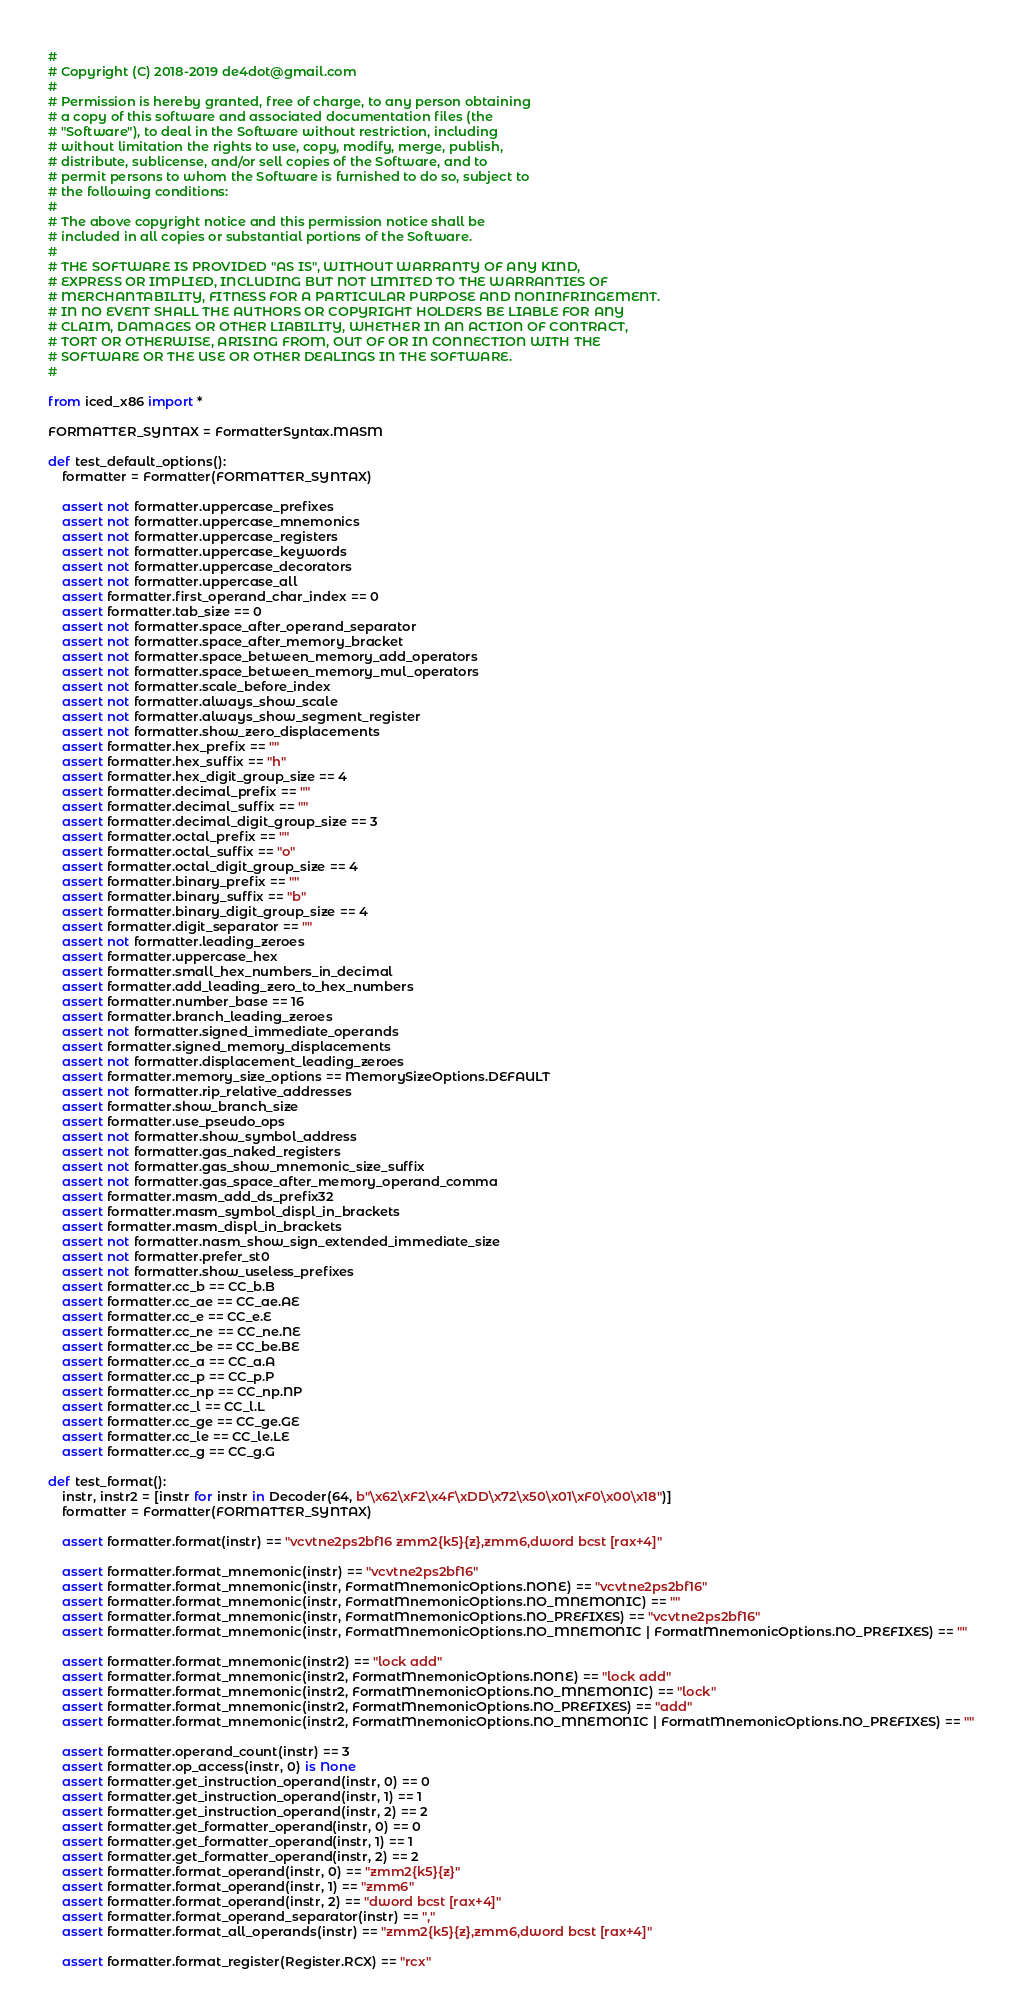<code> <loc_0><loc_0><loc_500><loc_500><_Python_>#
# Copyright (C) 2018-2019 de4dot@gmail.com
#
# Permission is hereby granted, free of charge, to any person obtaining
# a copy of this software and associated documentation files (the
# "Software"), to deal in the Software without restriction, including
# without limitation the rights to use, copy, modify, merge, publish,
# distribute, sublicense, and/or sell copies of the Software, and to
# permit persons to whom the Software is furnished to do so, subject to
# the following conditions:
#
# The above copyright notice and this permission notice shall be
# included in all copies or substantial portions of the Software.
#
# THE SOFTWARE IS PROVIDED "AS IS", WITHOUT WARRANTY OF ANY KIND,
# EXPRESS OR IMPLIED, INCLUDING BUT NOT LIMITED TO THE WARRANTIES OF
# MERCHANTABILITY, FITNESS FOR A PARTICULAR PURPOSE AND NONINFRINGEMENT.
# IN NO EVENT SHALL THE AUTHORS OR COPYRIGHT HOLDERS BE LIABLE FOR ANY
# CLAIM, DAMAGES OR OTHER LIABILITY, WHETHER IN AN ACTION OF CONTRACT,
# TORT OR OTHERWISE, ARISING FROM, OUT OF OR IN CONNECTION WITH THE
# SOFTWARE OR THE USE OR OTHER DEALINGS IN THE SOFTWARE.
#

from iced_x86 import *

FORMATTER_SYNTAX = FormatterSyntax.MASM

def test_default_options():
	formatter = Formatter(FORMATTER_SYNTAX)

	assert not formatter.uppercase_prefixes
	assert not formatter.uppercase_mnemonics
	assert not formatter.uppercase_registers
	assert not formatter.uppercase_keywords
	assert not formatter.uppercase_decorators
	assert not formatter.uppercase_all
	assert formatter.first_operand_char_index == 0
	assert formatter.tab_size == 0
	assert not formatter.space_after_operand_separator
	assert not formatter.space_after_memory_bracket
	assert not formatter.space_between_memory_add_operators
	assert not formatter.space_between_memory_mul_operators
	assert not formatter.scale_before_index
	assert not formatter.always_show_scale
	assert not formatter.always_show_segment_register
	assert not formatter.show_zero_displacements
	assert formatter.hex_prefix == ""
	assert formatter.hex_suffix == "h"
	assert formatter.hex_digit_group_size == 4
	assert formatter.decimal_prefix == ""
	assert formatter.decimal_suffix == ""
	assert formatter.decimal_digit_group_size == 3
	assert formatter.octal_prefix == ""
	assert formatter.octal_suffix == "o"
	assert formatter.octal_digit_group_size == 4
	assert formatter.binary_prefix == ""
	assert formatter.binary_suffix == "b"
	assert formatter.binary_digit_group_size == 4
	assert formatter.digit_separator == ""
	assert not formatter.leading_zeroes
	assert formatter.uppercase_hex
	assert formatter.small_hex_numbers_in_decimal
	assert formatter.add_leading_zero_to_hex_numbers
	assert formatter.number_base == 16
	assert formatter.branch_leading_zeroes
	assert not formatter.signed_immediate_operands
	assert formatter.signed_memory_displacements
	assert not formatter.displacement_leading_zeroes
	assert formatter.memory_size_options == MemorySizeOptions.DEFAULT
	assert not formatter.rip_relative_addresses
	assert formatter.show_branch_size
	assert formatter.use_pseudo_ops
	assert not formatter.show_symbol_address
	assert not formatter.gas_naked_registers
	assert not formatter.gas_show_mnemonic_size_suffix
	assert not formatter.gas_space_after_memory_operand_comma
	assert formatter.masm_add_ds_prefix32
	assert formatter.masm_symbol_displ_in_brackets
	assert formatter.masm_displ_in_brackets
	assert not formatter.nasm_show_sign_extended_immediate_size
	assert not formatter.prefer_st0
	assert not formatter.show_useless_prefixes
	assert formatter.cc_b == CC_b.B
	assert formatter.cc_ae == CC_ae.AE
	assert formatter.cc_e == CC_e.E
	assert formatter.cc_ne == CC_ne.NE
	assert formatter.cc_be == CC_be.BE
	assert formatter.cc_a == CC_a.A
	assert formatter.cc_p == CC_p.P
	assert formatter.cc_np == CC_np.NP
	assert formatter.cc_l == CC_l.L
	assert formatter.cc_ge == CC_ge.GE
	assert formatter.cc_le == CC_le.LE
	assert formatter.cc_g == CC_g.G

def test_format():
	instr, instr2 = [instr for instr in Decoder(64, b"\x62\xF2\x4F\xDD\x72\x50\x01\xF0\x00\x18")]
	formatter = Formatter(FORMATTER_SYNTAX)

	assert formatter.format(instr) == "vcvtne2ps2bf16 zmm2{k5}{z},zmm6,dword bcst [rax+4]"

	assert formatter.format_mnemonic(instr) == "vcvtne2ps2bf16"
	assert formatter.format_mnemonic(instr, FormatMnemonicOptions.NONE) == "vcvtne2ps2bf16"
	assert formatter.format_mnemonic(instr, FormatMnemonicOptions.NO_MNEMONIC) == ""
	assert formatter.format_mnemonic(instr, FormatMnemonicOptions.NO_PREFIXES) == "vcvtne2ps2bf16"
	assert formatter.format_mnemonic(instr, FormatMnemonicOptions.NO_MNEMONIC | FormatMnemonicOptions.NO_PREFIXES) == ""

	assert formatter.format_mnemonic(instr2) == "lock add"
	assert formatter.format_mnemonic(instr2, FormatMnemonicOptions.NONE) == "lock add"
	assert formatter.format_mnemonic(instr2, FormatMnemonicOptions.NO_MNEMONIC) == "lock"
	assert formatter.format_mnemonic(instr2, FormatMnemonicOptions.NO_PREFIXES) == "add"
	assert formatter.format_mnemonic(instr2, FormatMnemonicOptions.NO_MNEMONIC | FormatMnemonicOptions.NO_PREFIXES) == ""

	assert formatter.operand_count(instr) == 3
	assert formatter.op_access(instr, 0) is None
	assert formatter.get_instruction_operand(instr, 0) == 0
	assert formatter.get_instruction_operand(instr, 1) == 1
	assert formatter.get_instruction_operand(instr, 2) == 2
	assert formatter.get_formatter_operand(instr, 0) == 0
	assert formatter.get_formatter_operand(instr, 1) == 1
	assert formatter.get_formatter_operand(instr, 2) == 2
	assert formatter.format_operand(instr, 0) == "zmm2{k5}{z}"
	assert formatter.format_operand(instr, 1) == "zmm6"
	assert formatter.format_operand(instr, 2) == "dword bcst [rax+4]"
	assert formatter.format_operand_separator(instr) == ","
	assert formatter.format_all_operands(instr) == "zmm2{k5}{z},zmm6,dword bcst [rax+4]"

	assert formatter.format_register(Register.RCX) == "rcx"
</code> 